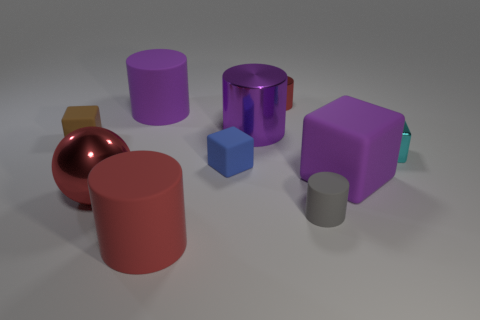Subtract all tiny cyan blocks. How many blocks are left? 3 Subtract 1 cubes. How many cubes are left? 3 Subtract all gray cylinders. How many cylinders are left? 4 Subtract all gray blocks. Subtract all red spheres. How many blocks are left? 4 Subtract all spheres. How many objects are left? 9 Subtract 0 yellow cylinders. How many objects are left? 10 Subtract all green rubber cylinders. Subtract all small brown cubes. How many objects are left? 9 Add 3 small gray cylinders. How many small gray cylinders are left? 4 Add 8 large brown rubber spheres. How many large brown rubber spheres exist? 8 